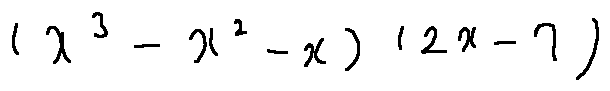<formula> <loc_0><loc_0><loc_500><loc_500>( x ^ { 3 } - x ^ { 2 } - x ) ( 2 x - 7 )</formula> 